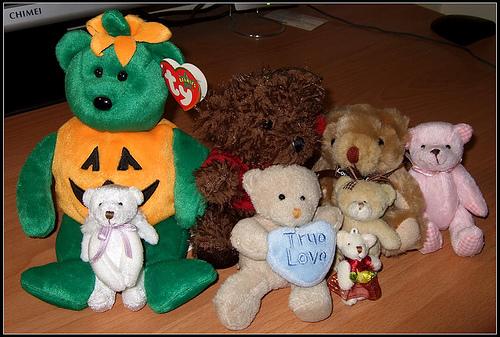What is the larger green bear dressed as?
Short answer required. Pumpkin. Are any of them wearing cowboy hats?
Concise answer only. No. Where is the pink bear?
Write a very short answer. Right. What color is the bear on the left''s hat?
Short answer required. Orange. How many bears are there?
Concise answer only. 8. What is the toys setting on?
Concise answer only. Table. What holiday are these toy's related to?
Answer briefly. Halloween. 